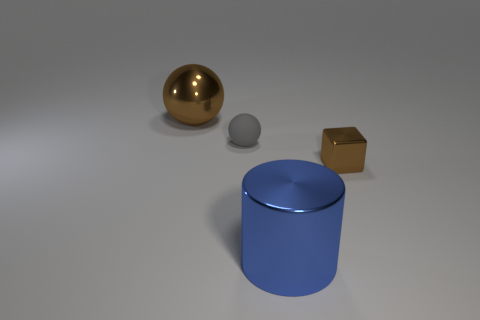If I were to arrange the objects by weight, which one would come first? If you were to arrange the objects by weight, based strictly on their appearance and assuming they are made of the materials they resemble, the small sphere would likely come first as it appears to be the smallest and possibly made of a lighter material like clay or plastic. The cube would likely follow, with the large sphere and cylinder being heavier, especially if they're metallic, with the large cylinder likely being the heaviest due to its size. 